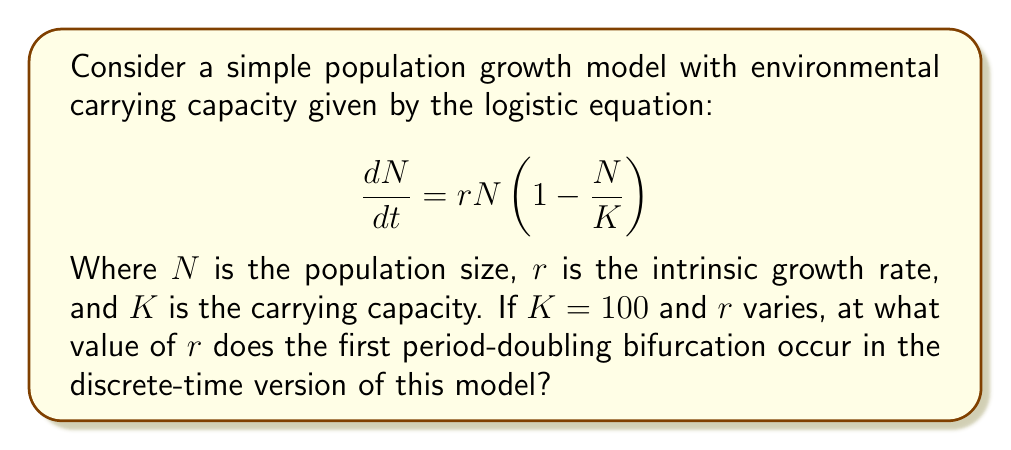Solve this math problem. To solve this problem, we need to follow these steps:

1) First, we need to convert the continuous-time model to a discrete-time model. The discrete-time version of the logistic equation is:

   $$N_{t+1} = rN_t\left(1 - \frac{N_t}{K}\right)$$

2) In this model, bifurcations occur as $r$ increases. The first period-doubling bifurcation occurs when the stability of the non-zero fixed point changes.

3) To find the fixed points, we set $N_{t+1} = N_t = N^*$:

   $$N^* = rN^*\left(1 - \frac{N^*}{K}\right)$$

4) Solving this equation gives us two fixed points: $N^* = 0$ and $N^* = K(1-1/r)$.

5) The stability of the non-zero fixed point changes when:

   $$\left|\frac{d}{dN}\left(rN\left(1 - \frac{N}{K}\right)\right)\right|_{N=N^*} = |-2 + r| = 1$$

6) Solving this equation:
   
   $-2 + r = 1$ or $-2 + r = -1$
   $r = 3$ or $r = 1$

7) The first period-doubling bifurcation occurs at the larger value, $r = 3$.

This result is independent of the specific value of $K$, so it holds for $K = 100$.
Answer: $r = 3$ 